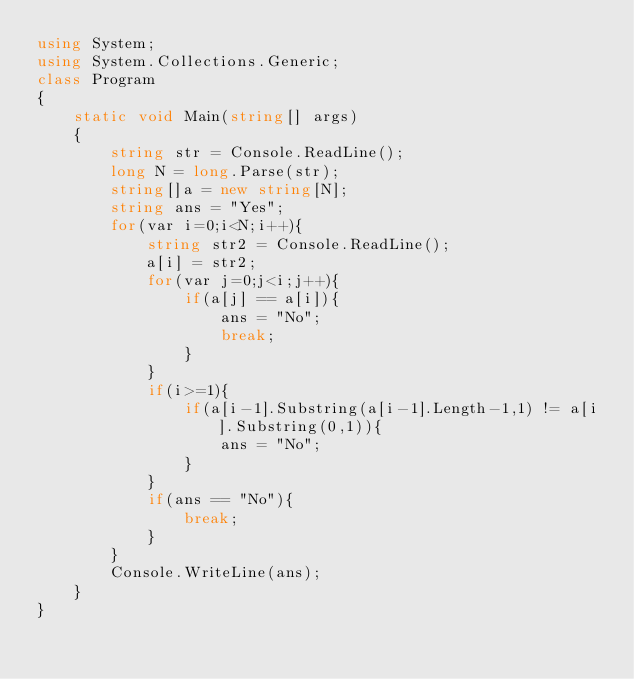<code> <loc_0><loc_0><loc_500><loc_500><_C#_>using System;
using System.Collections.Generic;
class Program
{
	static void Main(string[] args)
	{
		string str = Console.ReadLine();
		long N = long.Parse(str);
		string[]a = new string[N];
		string ans = "Yes";
		for(var i=0;i<N;i++){
			string str2 = Console.ReadLine();
			a[i] = str2;
			for(var j=0;j<i;j++){
				if(a[j] == a[i]){
					ans = "No";
					break;
				}
			}
			if(i>=1){
				if(a[i-1].Substring(a[i-1].Length-1,1) != a[i].Substring(0,1)){
					ans = "No";
				}
			}
			if(ans == "No"){
				break;
			}
		}
		Console.WriteLine(ans);
	}
}</code> 